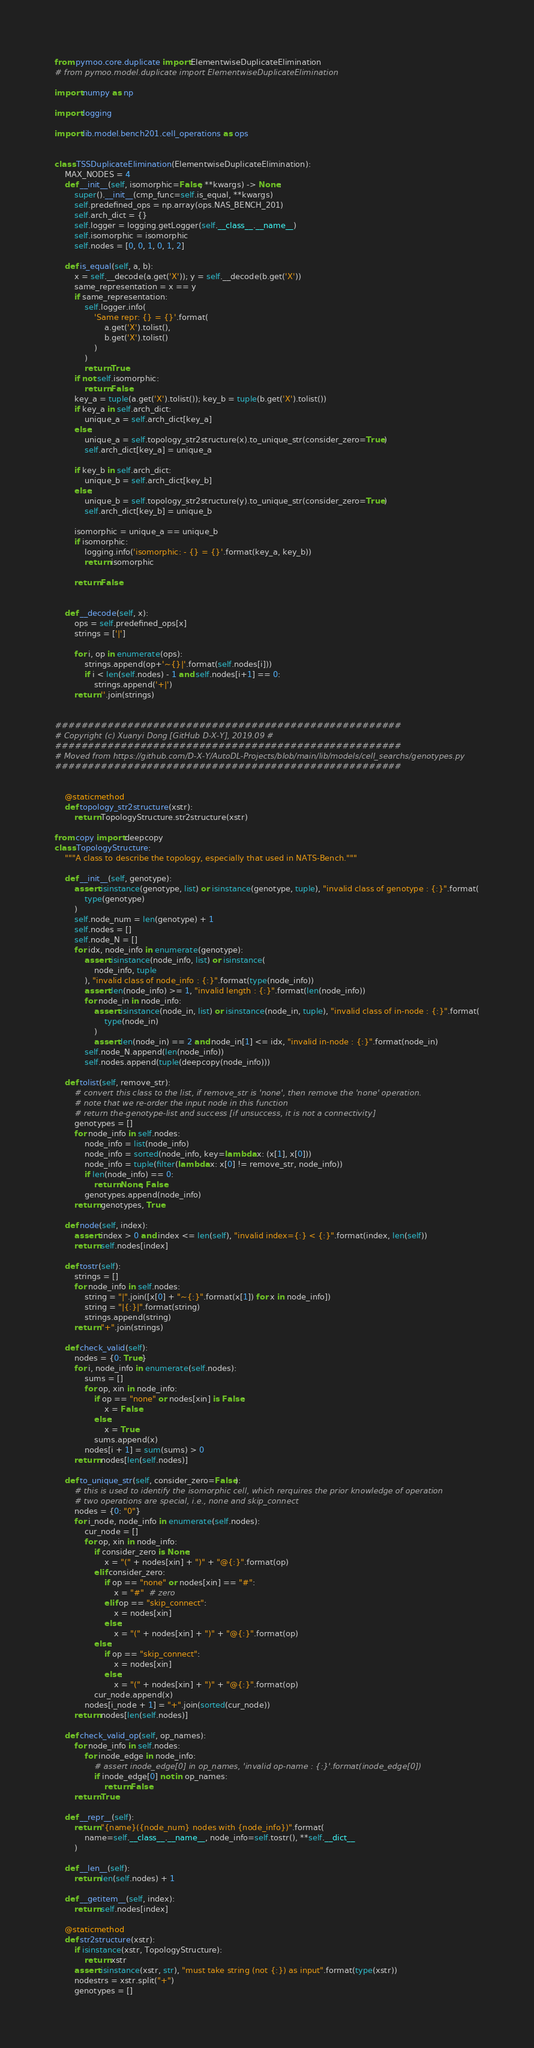<code> <loc_0><loc_0><loc_500><loc_500><_Python_>from pymoo.core.duplicate import ElementwiseDuplicateElimination
# from pymoo.model.duplicate import ElementwiseDuplicateElimination

import numpy as np

import logging

import lib.model.bench201.cell_operations as ops


class TSSDuplicateElimination(ElementwiseDuplicateElimination):
    MAX_NODES = 4
    def __init__(self, isomorphic=False, **kwargs) -> None:
        super().__init__(cmp_func=self.is_equal, **kwargs)
        self.predefined_ops = np.array(ops.NAS_BENCH_201)
        self.arch_dict = {}
        self.logger = logging.getLogger(self.__class__.__name__)
        self.isomorphic = isomorphic
        self.nodes = [0, 0, 1, 0, 1, 2]

    def is_equal(self, a, b):
        x = self.__decode(a.get('X')); y = self.__decode(b.get('X'))
        same_representation = x == y
        if same_representation:
            self.logger.info(
                'Same repr: {} = {}'.format(
                    a.get('X').tolist(), 
                    b.get('X').tolist()
                )
            )
            return True
        if not self.isomorphic:
            return False
        key_a = tuple(a.get('X').tolist()); key_b = tuple(b.get('X').tolist())
        if key_a in self.arch_dict:
            unique_a = self.arch_dict[key_a]
        else:
            unique_a = self.topology_str2structure(x).to_unique_str(consider_zero=True)
            self.arch_dict[key_a] = unique_a
        
        if key_b in self.arch_dict:
            unique_b = self.arch_dict[key_b]
        else:
            unique_b = self.topology_str2structure(y).to_unique_str(consider_zero=True)
            self.arch_dict[key_b] = unique_b
        
        isomorphic = unique_a == unique_b
        if isomorphic:
            logging.info('isomorphic: - {} = {}'.format(key_a, key_b))
            return isomorphic

        return False


    def __decode(self, x):
        ops = self.predefined_ops[x]
        strings = ['|']

        for i, op in enumerate(ops):
            strings.append(op+'~{}|'.format(self.nodes[i]))
            if i < len(self.nodes) - 1 and self.nodes[i+1] == 0:
                strings.append('+|')
        return ''.join(strings)


#####################################################
# Copyright (c) Xuanyi Dong [GitHub D-X-Y], 2019.09 #
#####################################################
# Moved from https://github.com/D-X-Y/AutoDL-Projects/blob/main/lib/models/cell_searchs/genotypes.py
#####################################################


    @staticmethod
    def topology_str2structure(xstr):
        return TopologyStructure.str2structure(xstr)

from copy import deepcopy
class TopologyStructure:
    """A class to describe the topology, especially that used in NATS-Bench."""

    def __init__(self, genotype):
        assert isinstance(genotype, list) or isinstance(genotype, tuple), "invalid class of genotype : {:}".format(
            type(genotype)
        )
        self.node_num = len(genotype) + 1
        self.nodes = []
        self.node_N = []
        for idx, node_info in enumerate(genotype):
            assert isinstance(node_info, list) or isinstance(
                node_info, tuple
            ), "invalid class of node_info : {:}".format(type(node_info))
            assert len(node_info) >= 1, "invalid length : {:}".format(len(node_info))
            for node_in in node_info:
                assert isinstance(node_in, list) or isinstance(node_in, tuple), "invalid class of in-node : {:}".format(
                    type(node_in)
                )
                assert len(node_in) == 2 and node_in[1] <= idx, "invalid in-node : {:}".format(node_in)
            self.node_N.append(len(node_info))
            self.nodes.append(tuple(deepcopy(node_info)))

    def tolist(self, remove_str):
        # convert this class to the list, if remove_str is 'none', then remove the 'none' operation.
        # note that we re-order the input node in this function
        # return the-genotype-list and success [if unsuccess, it is not a connectivity]
        genotypes = []
        for node_info in self.nodes:
            node_info = list(node_info)
            node_info = sorted(node_info, key=lambda x: (x[1], x[0]))
            node_info = tuple(filter(lambda x: x[0] != remove_str, node_info))
            if len(node_info) == 0:
                return None, False
            genotypes.append(node_info)
        return genotypes, True

    def node(self, index):
        assert index > 0 and index <= len(self), "invalid index={:} < {:}".format(index, len(self))
        return self.nodes[index]

    def tostr(self):
        strings = []
        for node_info in self.nodes:
            string = "|".join([x[0] + "~{:}".format(x[1]) for x in node_info])
            string = "|{:}|".format(string)
            strings.append(string)
        return "+".join(strings)

    def check_valid(self):
        nodes = {0: True}
        for i, node_info in enumerate(self.nodes):
            sums = []
            for op, xin in node_info:
                if op == "none" or nodes[xin] is False:
                    x = False
                else:
                    x = True
                sums.append(x)
            nodes[i + 1] = sum(sums) > 0
        return nodes[len(self.nodes)]

    def to_unique_str(self, consider_zero=False):
        # this is used to identify the isomorphic cell, which rerquires the prior knowledge of operation
        # two operations are special, i.e., none and skip_connect
        nodes = {0: "0"}
        for i_node, node_info in enumerate(self.nodes):
            cur_node = []
            for op, xin in node_info:
                if consider_zero is None:
                    x = "(" + nodes[xin] + ")" + "@{:}".format(op)
                elif consider_zero:
                    if op == "none" or nodes[xin] == "#":
                        x = "#"  # zero
                    elif op == "skip_connect":
                        x = nodes[xin]
                    else:
                        x = "(" + nodes[xin] + ")" + "@{:}".format(op)
                else:
                    if op == "skip_connect":
                        x = nodes[xin]
                    else:
                        x = "(" + nodes[xin] + ")" + "@{:}".format(op)
                cur_node.append(x)
            nodes[i_node + 1] = "+".join(sorted(cur_node))
        return nodes[len(self.nodes)]

    def check_valid_op(self, op_names):
        for node_info in self.nodes:
            for inode_edge in node_info:
                # assert inode_edge[0] in op_names, 'invalid op-name : {:}'.format(inode_edge[0])
                if inode_edge[0] not in op_names:
                    return False
        return True

    def __repr__(self):
        return "{name}({node_num} nodes with {node_info})".format(
            name=self.__class__.__name__, node_info=self.tostr(), **self.__dict__
        )

    def __len__(self):
        return len(self.nodes) + 1

    def __getitem__(self, index):
        return self.nodes[index]

    @staticmethod
    def str2structure(xstr):
        if isinstance(xstr, TopologyStructure):
            return xstr
        assert isinstance(xstr, str), "must take string (not {:}) as input".format(type(xstr))
        nodestrs = xstr.split("+")
        genotypes = []</code> 